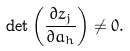Convert formula to latex. <formula><loc_0><loc_0><loc_500><loc_500>\det \left ( \frac { \partial z _ { j } } { \partial a _ { h } } \right ) \neq 0 .</formula> 